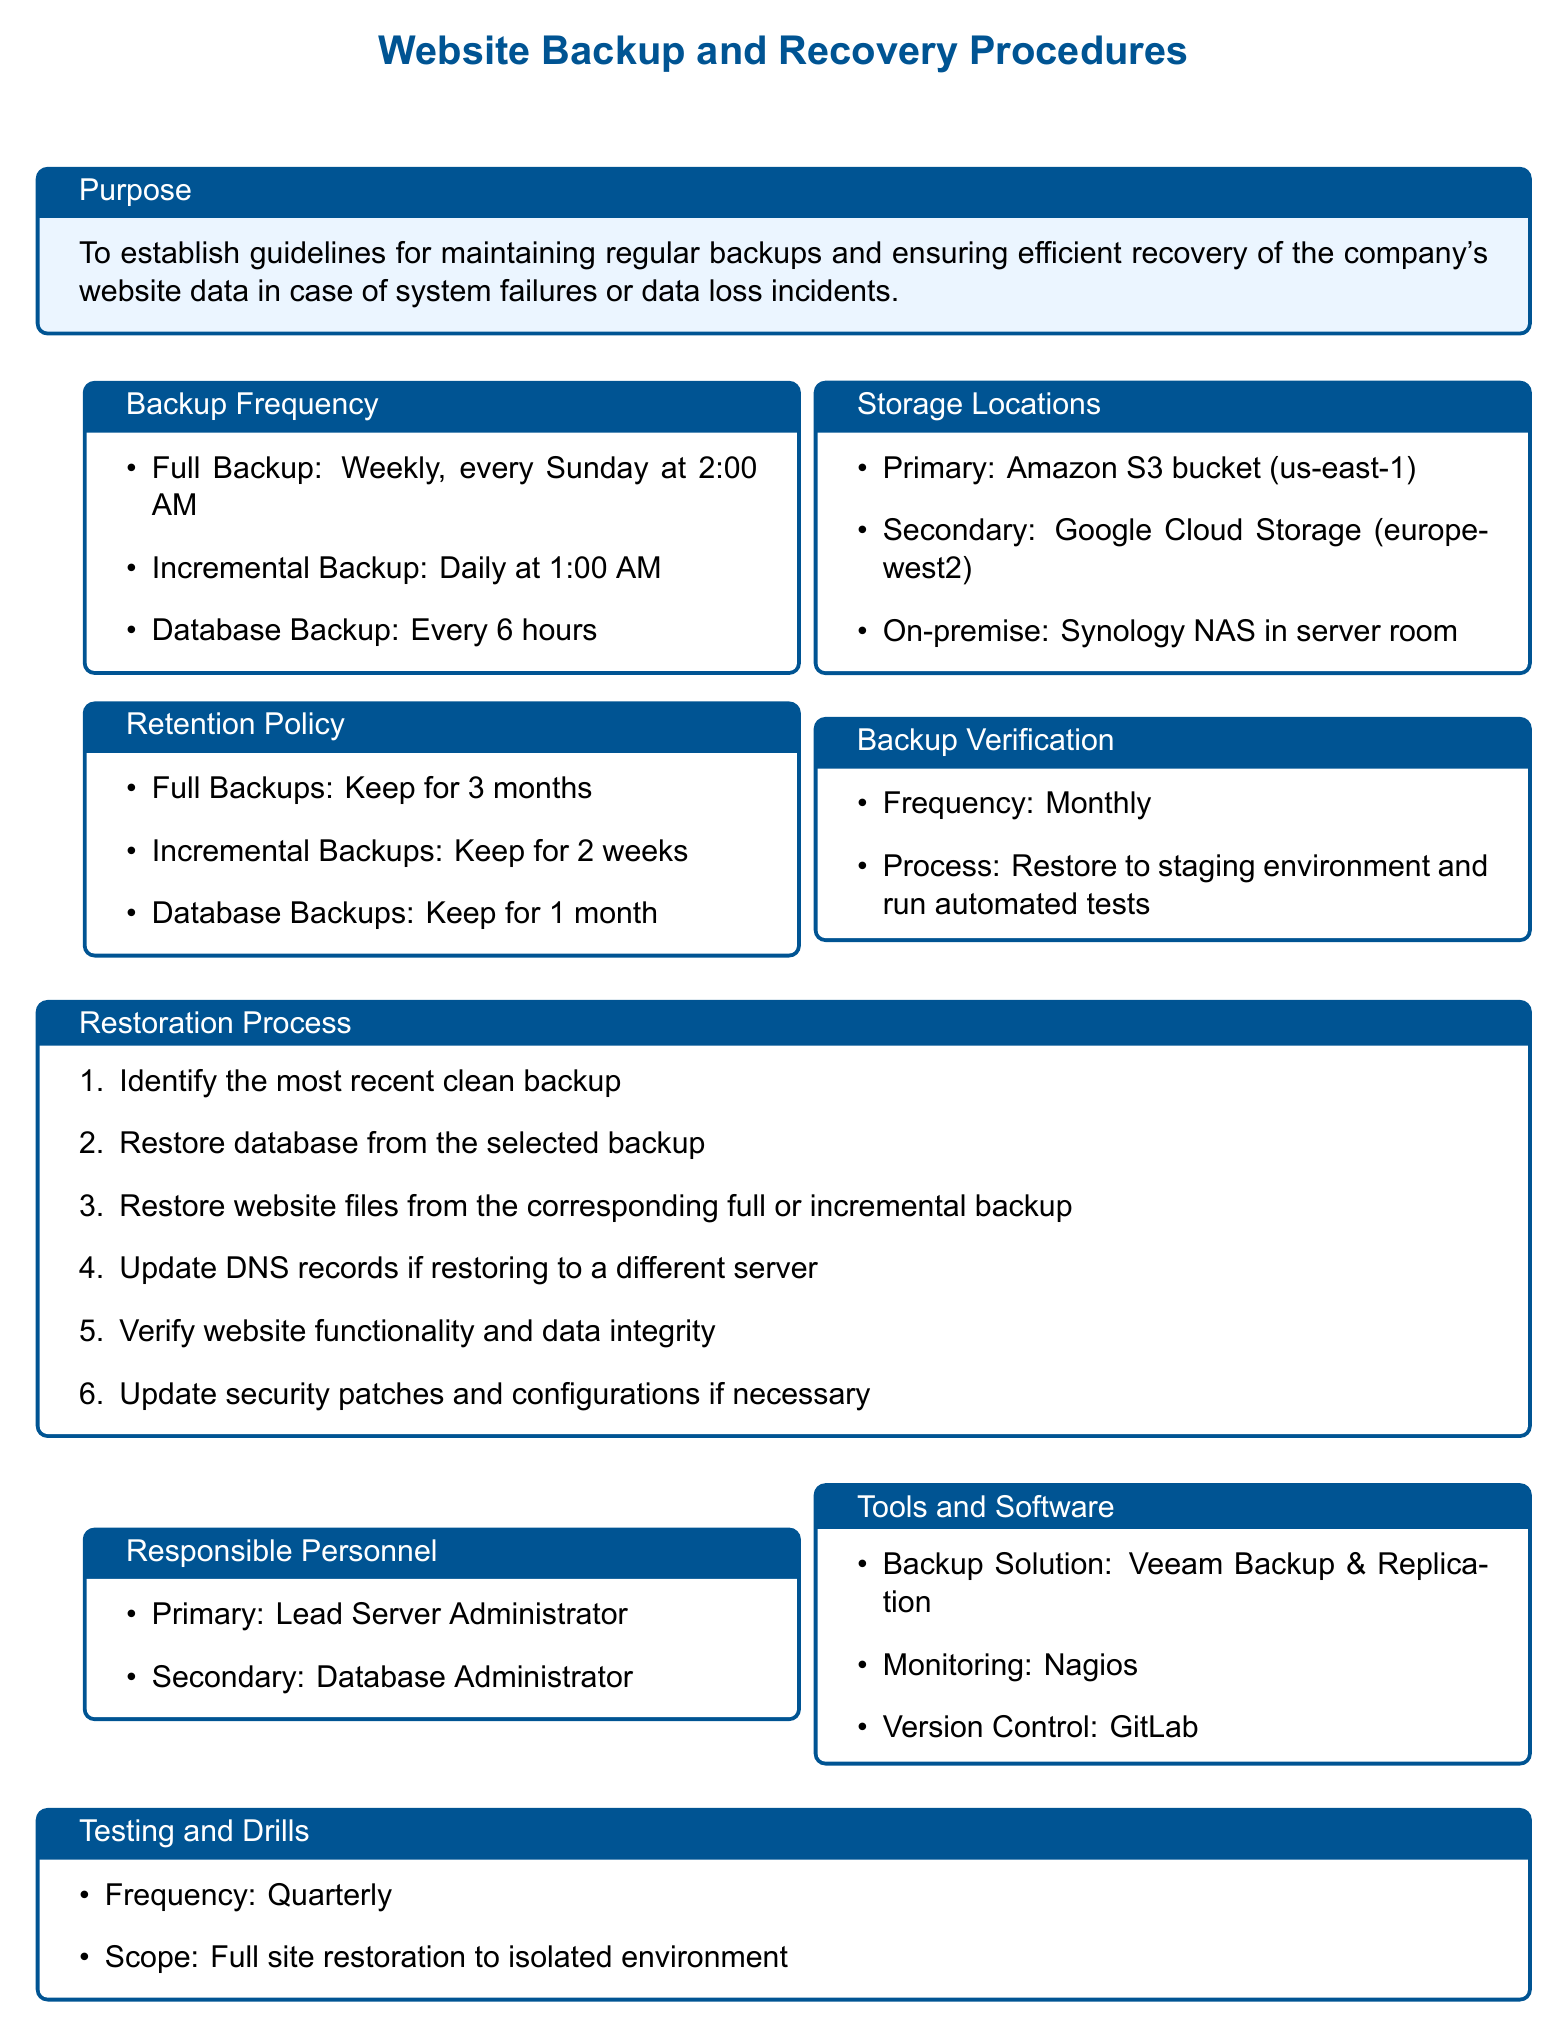What is the frequency of Full Backups? The document states that Full Backups are done weekly, every Sunday at 2:00 AM.
Answer: Weekly, every Sunday at 2:00 AM Where are the Primary storage locations for backups? The document lists Amazon S3 bucket (us-east-1) as the Primary storage location.
Answer: Amazon S3 bucket (us-east-1) How long are Incremental Backups retained? According to the document, Incremental Backups are kept for 2 weeks.
Answer: 2 weeks What is the process to verify backups? The document outlines that the backups are to be restored to a staging environment and automated tests are run.
Answer: Restore to staging environment and run automated tests Who is the primary responsible personnel for backups? The document identifies the Lead Server Administrator as the primary responsible personnel.
Answer: Lead Server Administrator How often are testing and drills conducted? The document specifies that testing and drills are conducted quarterly.
Answer: Quarterly What type of backup solution is mentioned in the document? The document mentions Veeam Backup & Replication as the backup solution.
Answer: Veeam Backup & Replication What is the first step in the Restoration Process? The document states that the first step is to identify the most recent clean backup.
Answer: Identify the most recent clean backup How frequently are Database Backups taken? The document states that Database Backups are taken every 6 hours.
Answer: Every 6 hours 